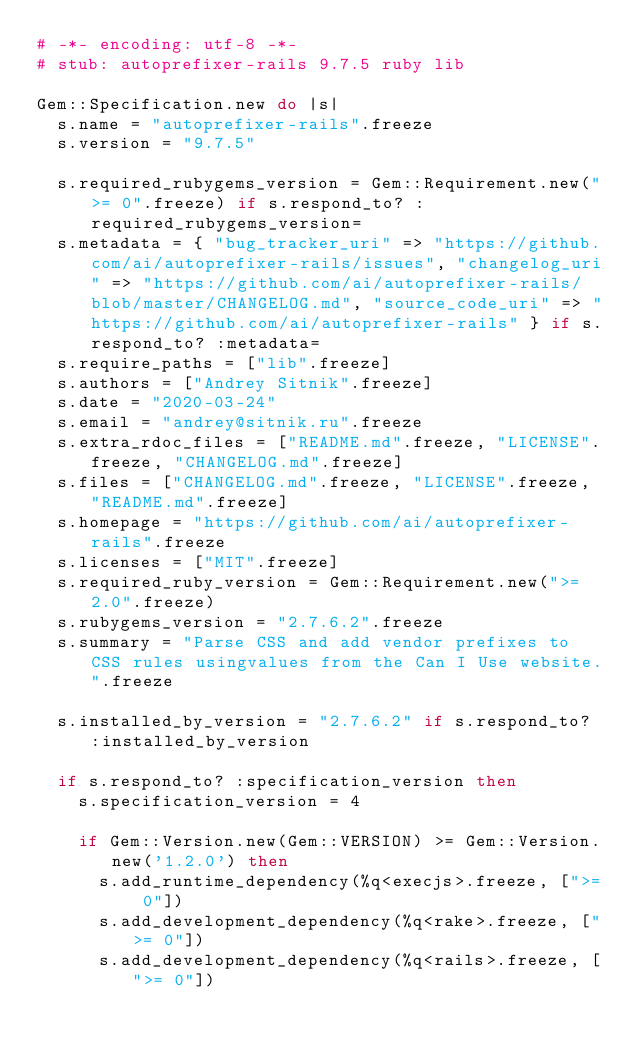<code> <loc_0><loc_0><loc_500><loc_500><_Ruby_># -*- encoding: utf-8 -*-
# stub: autoprefixer-rails 9.7.5 ruby lib

Gem::Specification.new do |s|
  s.name = "autoprefixer-rails".freeze
  s.version = "9.7.5"

  s.required_rubygems_version = Gem::Requirement.new(">= 0".freeze) if s.respond_to? :required_rubygems_version=
  s.metadata = { "bug_tracker_uri" => "https://github.com/ai/autoprefixer-rails/issues", "changelog_uri" => "https://github.com/ai/autoprefixer-rails/blob/master/CHANGELOG.md", "source_code_uri" => "https://github.com/ai/autoprefixer-rails" } if s.respond_to? :metadata=
  s.require_paths = ["lib".freeze]
  s.authors = ["Andrey Sitnik".freeze]
  s.date = "2020-03-24"
  s.email = "andrey@sitnik.ru".freeze
  s.extra_rdoc_files = ["README.md".freeze, "LICENSE".freeze, "CHANGELOG.md".freeze]
  s.files = ["CHANGELOG.md".freeze, "LICENSE".freeze, "README.md".freeze]
  s.homepage = "https://github.com/ai/autoprefixer-rails".freeze
  s.licenses = ["MIT".freeze]
  s.required_ruby_version = Gem::Requirement.new(">= 2.0".freeze)
  s.rubygems_version = "2.7.6.2".freeze
  s.summary = "Parse CSS and add vendor prefixes to CSS rules usingvalues from the Can I Use website.".freeze

  s.installed_by_version = "2.7.6.2" if s.respond_to? :installed_by_version

  if s.respond_to? :specification_version then
    s.specification_version = 4

    if Gem::Version.new(Gem::VERSION) >= Gem::Version.new('1.2.0') then
      s.add_runtime_dependency(%q<execjs>.freeze, [">= 0"])
      s.add_development_dependency(%q<rake>.freeze, [">= 0"])
      s.add_development_dependency(%q<rails>.freeze, [">= 0"])</code> 